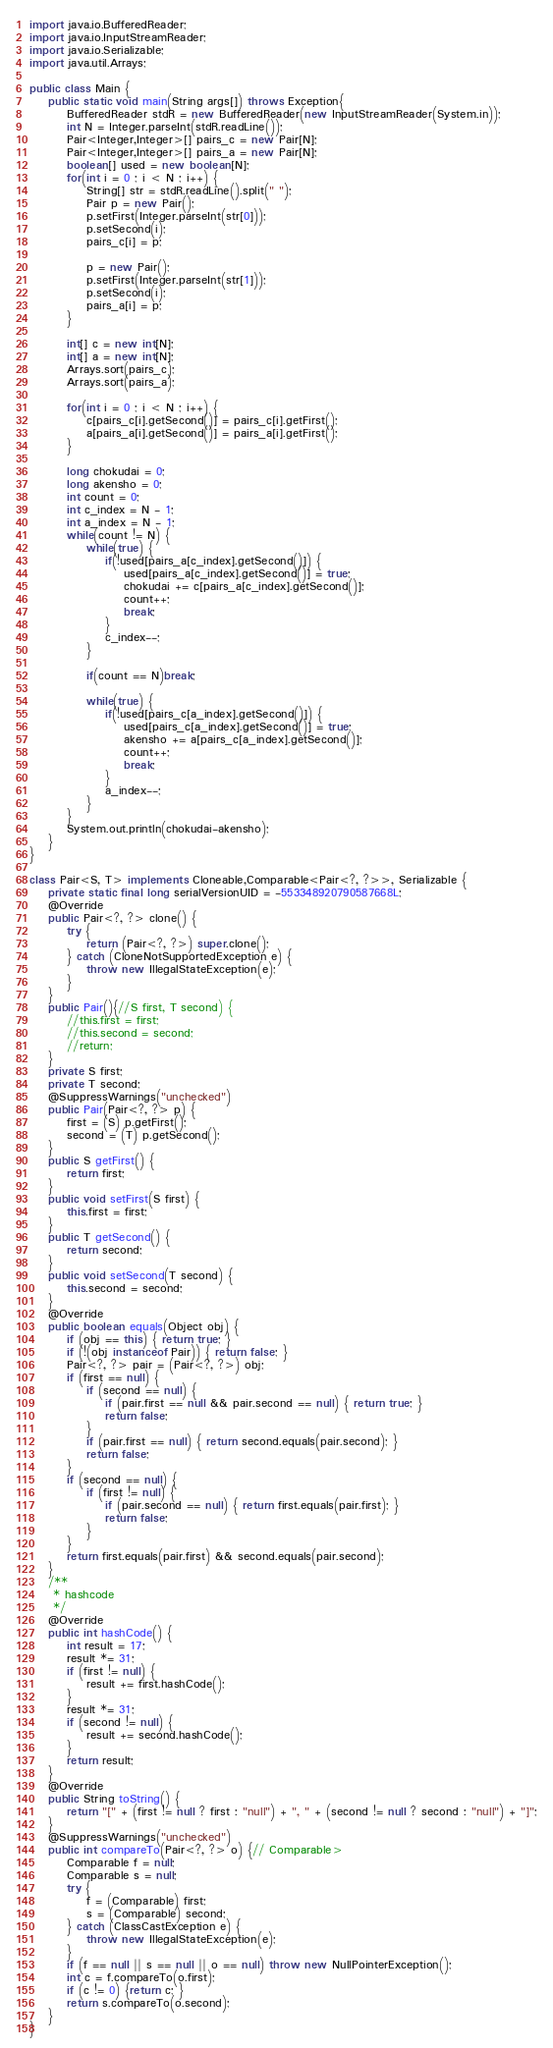<code> <loc_0><loc_0><loc_500><loc_500><_Java_>import java.io.BufferedReader;
import java.io.InputStreamReader;
import java.io.Serializable;
import java.util.Arrays;

public class Main {
    public static void main(String args[]) throws Exception{
        BufferedReader stdR = new BufferedReader(new InputStreamReader(System.in));
        int N = Integer.parseInt(stdR.readLine());
        Pair<Integer,Integer>[] pairs_c = new Pair[N];
        Pair<Integer,Integer>[] pairs_a = new Pair[N];
        boolean[] used = new boolean[N];
        for(int i = 0 ; i < N ; i++) {
            String[] str = stdR.readLine().split(" ");
            Pair p = new Pair();
            p.setFirst(Integer.parseInt(str[0]));
            p.setSecond(i);
            pairs_c[i] = p;
            
            p = new Pair();
            p.setFirst(Integer.parseInt(str[1]));
            p.setSecond(i);
            pairs_a[i] = p;
        }

        int[] c = new int[N];
        int[] a = new int[N];
        Arrays.sort(pairs_c);
        Arrays.sort(pairs_a);
        
        for(int i = 0 ; i < N ; i++) {
            c[pairs_c[i].getSecond()] = pairs_c[i].getFirst();
            a[pairs_a[i].getSecond()] = pairs_a[i].getFirst();
        }
        
        long chokudai = 0;
        long akensho = 0;
        int count = 0;
        int c_index = N - 1;
        int a_index = N - 1;
        while(count != N) {
            while(true) {
                if(!used[pairs_a[c_index].getSecond()]) {
                    used[pairs_a[c_index].getSecond()] = true;
                    chokudai += c[pairs_a[c_index].getSecond()];
                    count++;
                    break;
                }
                c_index--;
            }
            
            if(count == N)break;
            
            while(true) {
                if(!used[pairs_c[a_index].getSecond()]) {
                    used[pairs_c[a_index].getSecond()] = true;
                    akensho += a[pairs_c[a_index].getSecond()];
                    count++;
                    break;
                }
                a_index--;
            }
        }
        System.out.println(chokudai-akensho);
    }
}

class Pair<S, T> implements Cloneable,Comparable<Pair<?, ?>>, Serializable {
    private static final long serialVersionUID = -553348920790587668L;
    @Override
    public Pair<?, ?> clone() {
        try {
            return (Pair<?, ?>) super.clone();
        } catch (CloneNotSupportedException e) {
            throw new IllegalStateException(e);
        }
    }
    public Pair(){//S first, T second) {
        //this.first = first;
        //this.second = second;
        //return;
    }
    private S first;
    private T second;
    @SuppressWarnings("unchecked")
    public Pair(Pair<?, ?> p) {
        first = (S) p.getFirst();
        second = (T) p.getSecond();
    }
    public S getFirst() {
        return first;
    }
    public void setFirst(S first) {
        this.first = first;
    }
    public T getSecond() {
        return second;
    }
    public void setSecond(T second) {
        this.second = second;
    }
    @Override
    public boolean equals(Object obj) {
        if (obj == this) { return true; }
        if (!(obj instanceof Pair)) { return false; }
        Pair<?, ?> pair = (Pair<?, ?>) obj;
        if (first == null) {
            if (second == null) {
                if (pair.first == null && pair.second == null) { return true; }
                return false;
            }
            if (pair.first == null) { return second.equals(pair.second); }
            return false;
        }
        if (second == null) {
            if (first != null) {
                if (pair.second == null) { return first.equals(pair.first); }
                return false;
            }
        }
        return first.equals(pair.first) && second.equals(pair.second);
    }
    /**
     * hashcode
     */
    @Override
    public int hashCode() {
        int result = 17;
        result *= 31;
        if (first != null) {
            result += first.hashCode();
        }
        result *= 31;
        if (second != null) {
            result += second.hashCode();
        }
        return result;
    }
    @Override
    public String toString() {
        return "[" + (first != null ? first : "null") + ", " + (second != null ? second : "null") + "]";
    }
    @SuppressWarnings("unchecked")
    public int compareTo(Pair<?, ?> o) {// Comparable>
        Comparable f = null;
        Comparable s = null;
        try {
            f = (Comparable) first;
            s = (Comparable) second;
        } catch (ClassCastException e) {
            throw new IllegalStateException(e);
        }
        if (f == null || s == null || o == null) throw new NullPointerException();
        int c = f.compareTo(o.first);
        if (c != 0) {return c; }
        return s.compareTo(o.second);
    }
}
</code> 